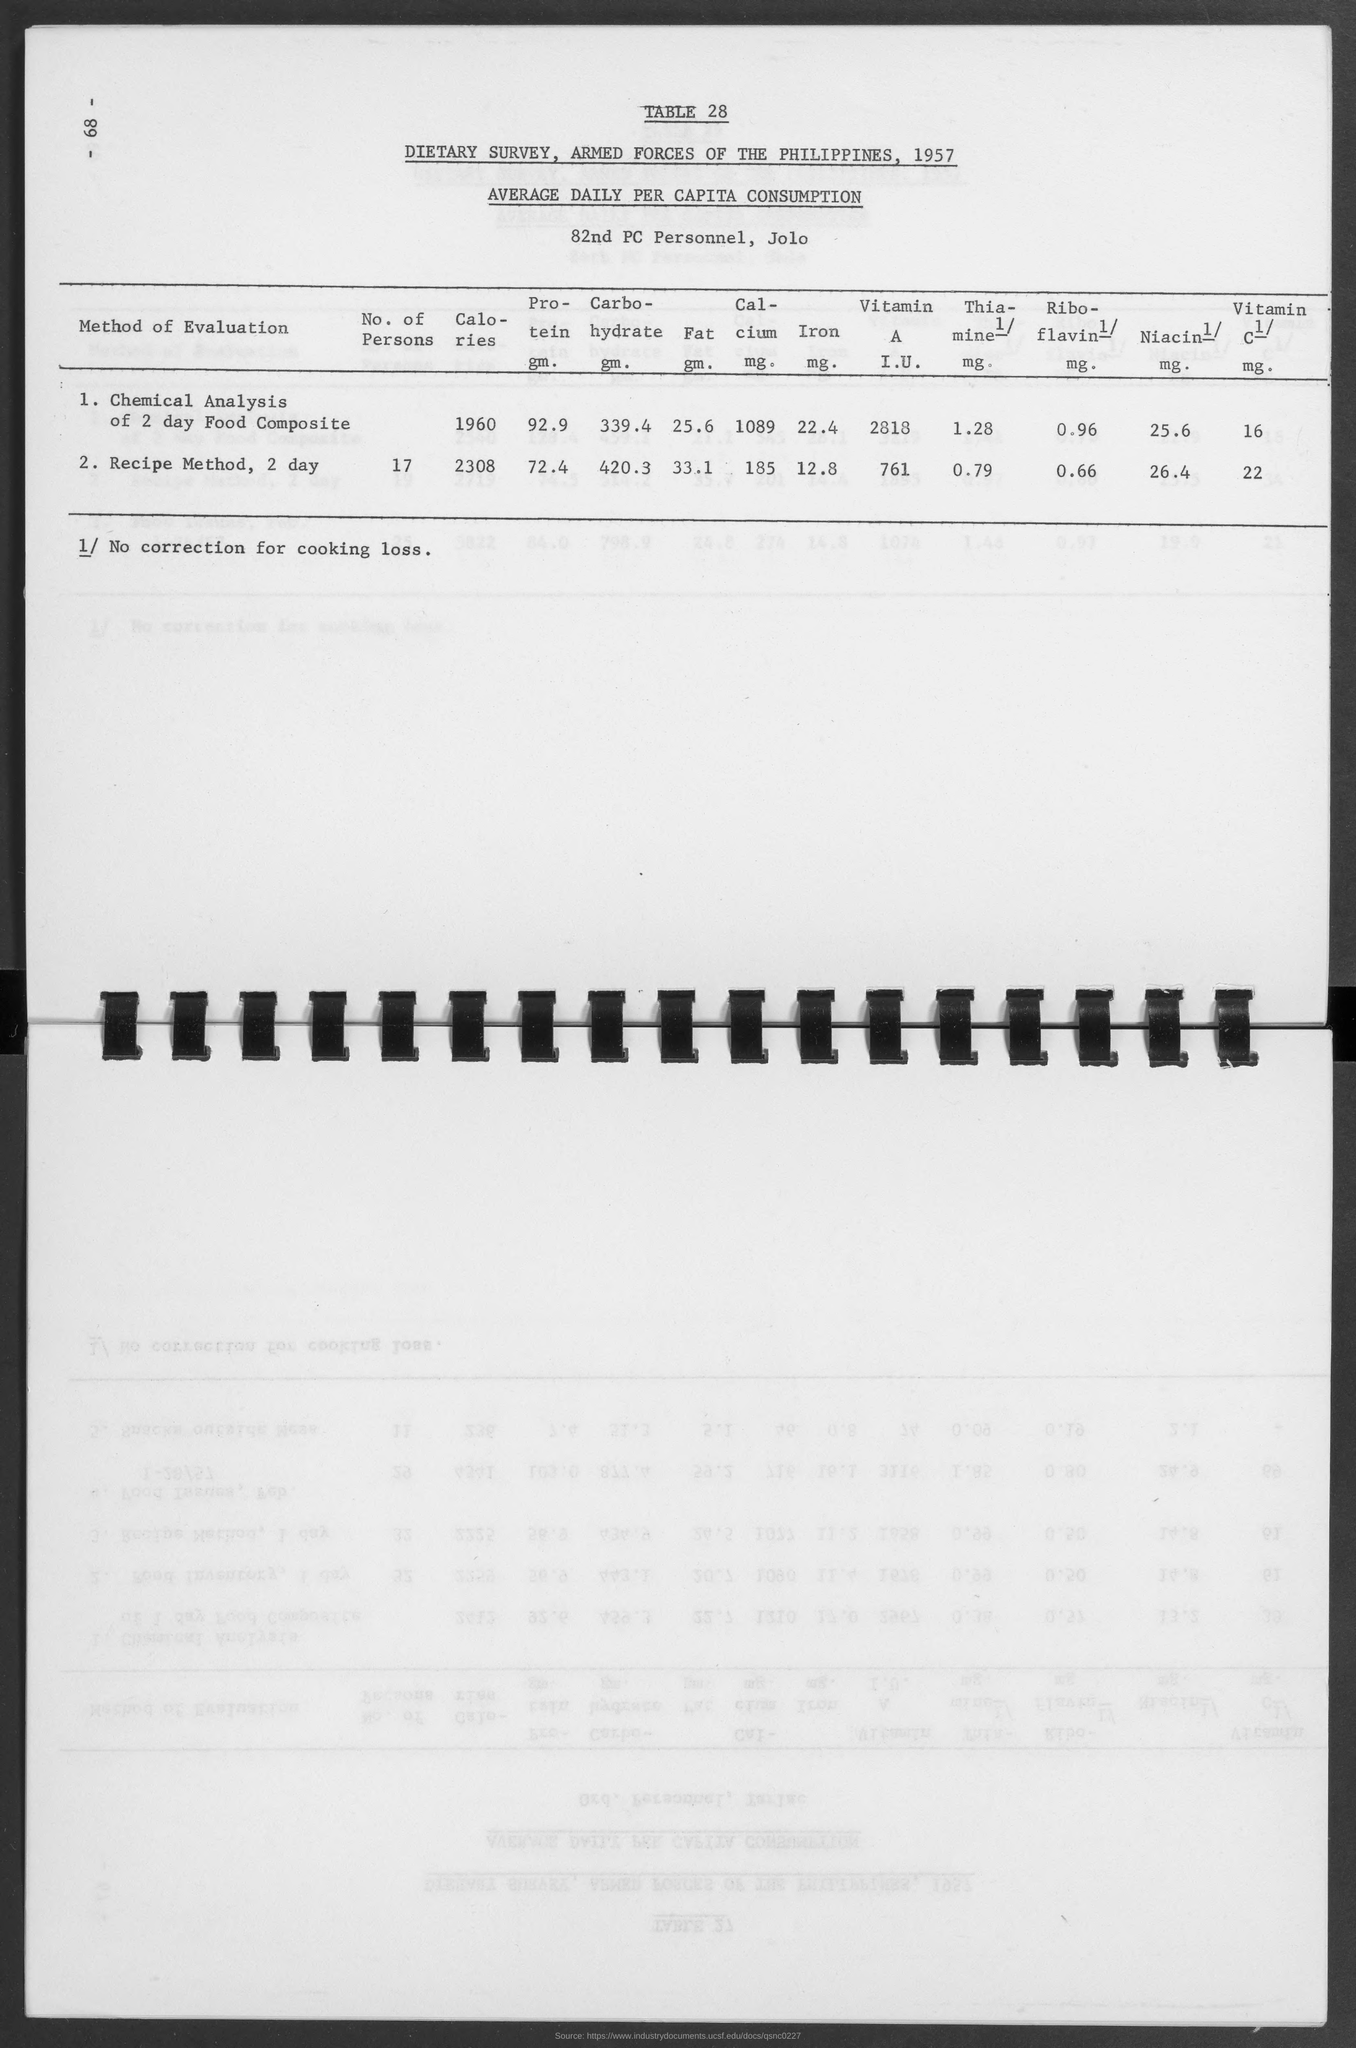Give some essential details in this illustration. The calcium content for the chemical analysis of a 2-day food composite is 1089 milligrams. The fat content of a 2-day food composite has been determined to be 25.6 gm through chemical analysis. What is the riboflavin content for the chemical analysis of a 2-day food composite? The value is 0.96 mg. The chemical analysis of a 2-day food composite requires a certain quantity of protein, specifically 92.9 grams. The vitamin A I.U. values for a 2-day food composite are 2818. 